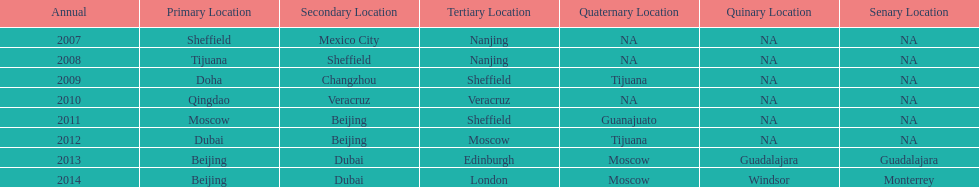What years had the most venues? 2013, 2014. 